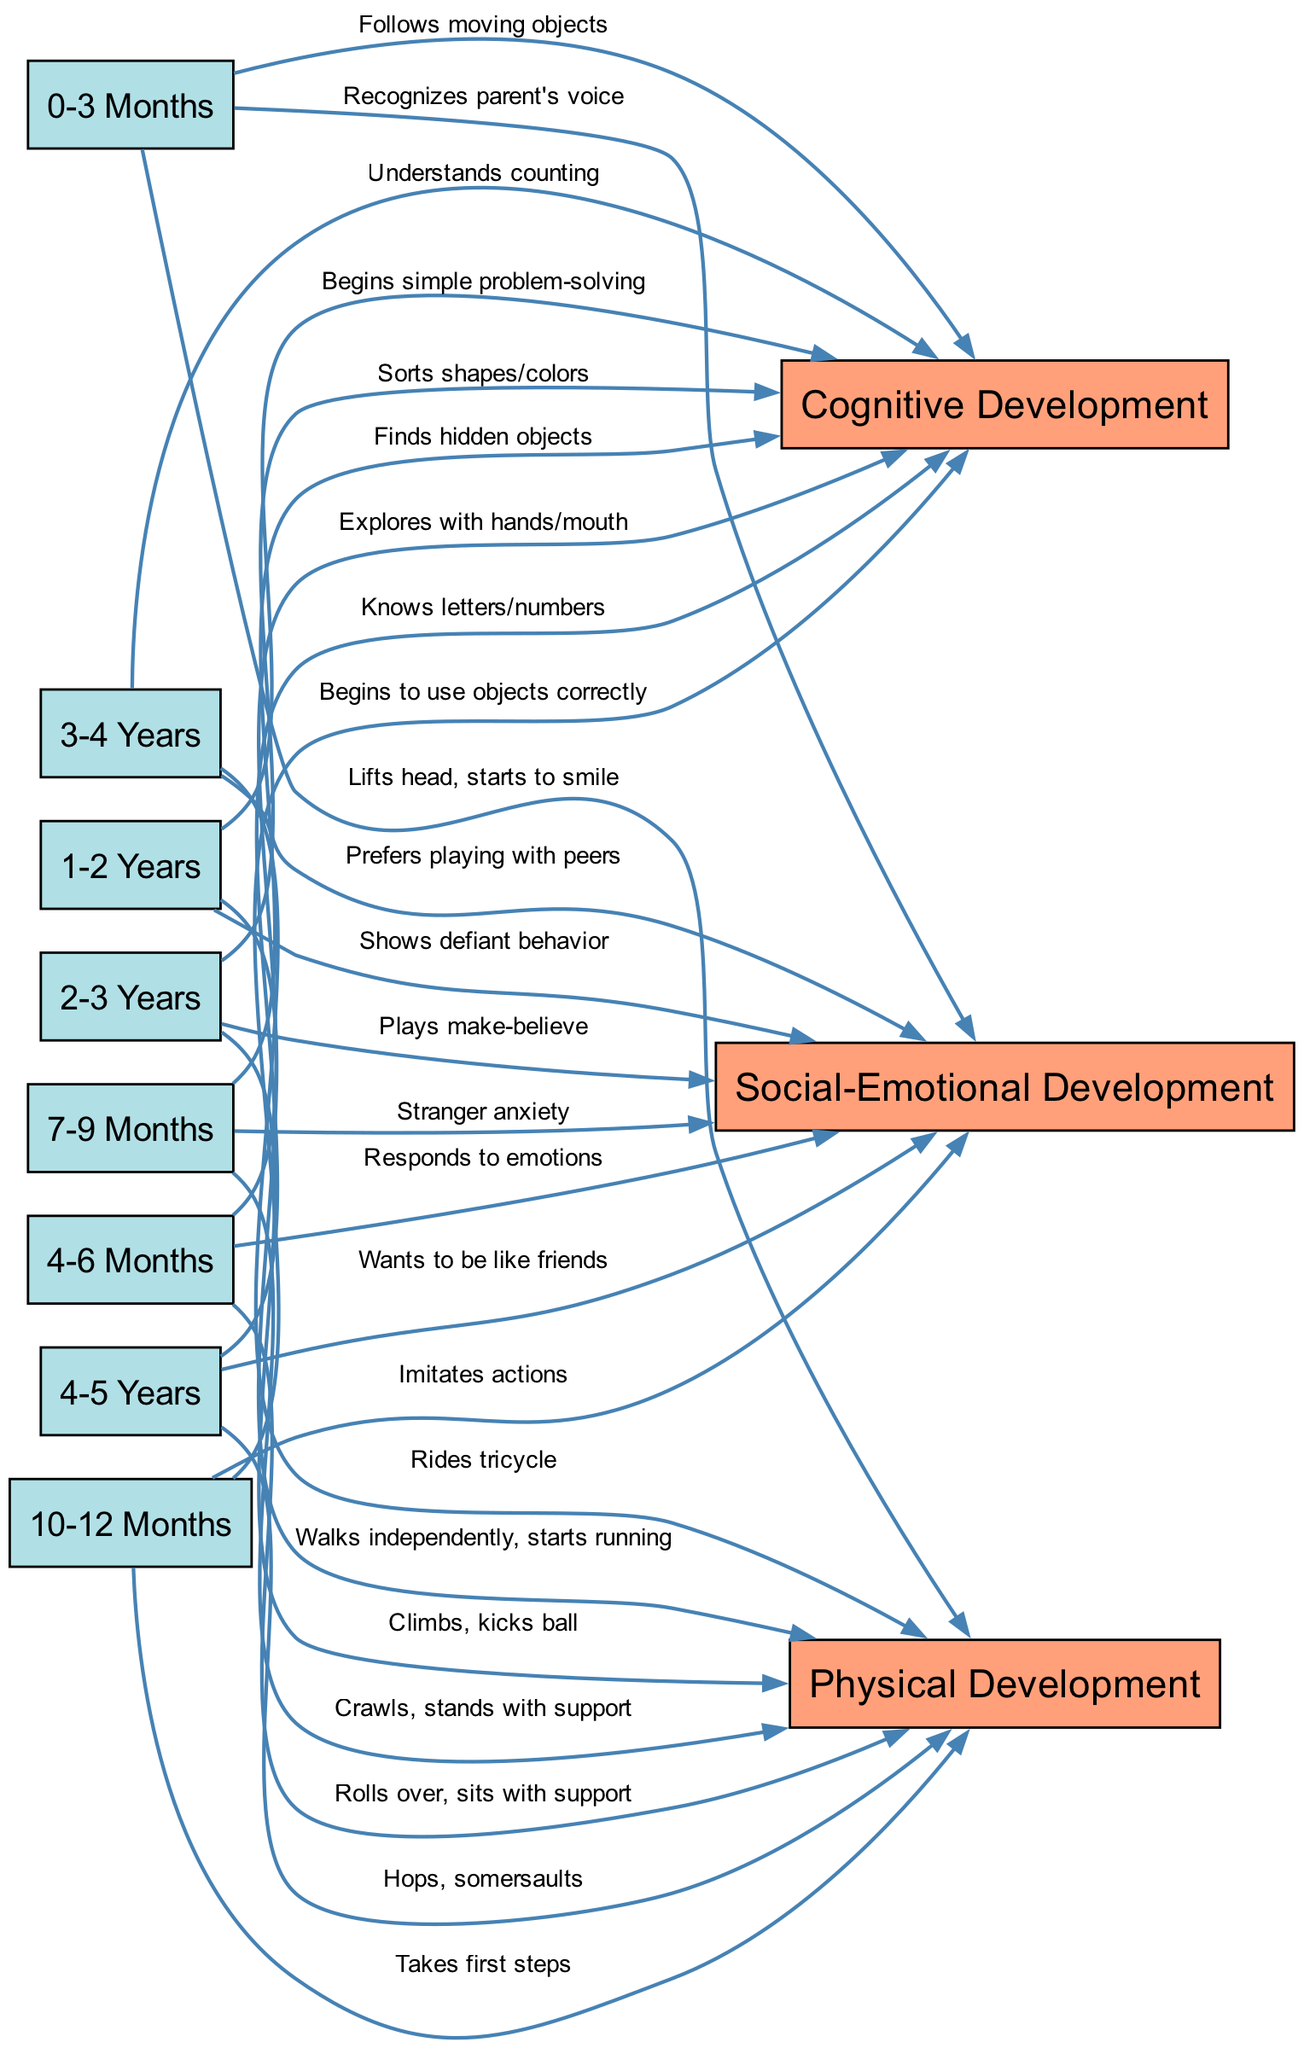What milestones are associated with 1-2 years? The diagram shows three connections for the 1-2 years node: "Walks independently, starts running" for physical development, "Begins simple problem-solving" for cognitive development, and "Shows defiant behavior" for social-emotional development.
Answer: Walks independently, starts running; Begins simple problem-solving; Shows defiant behavior How many nodes are there? The diagram includes a total of 12 nodes which represent both age ranges and types of development.
Answer: 12 What does the 4-6 months node connect to for cognitive development? In the diagram, the 4-6 months node connects to the cognitive development node with the label "Explores with hands/mouth."
Answer: Explores with hands/mouth Which age range corresponds to the milestone "Rides tricycle"? The milestone "Rides tricycle" is connected from the node "3-4 Years." This identifies the age range associated with that specific physical milestone.
Answer: 3-4 Years What is the first milestone in physical development? The diagram connects the 0-3 months node to physical development for the milestone "Lifts head, starts to smile," marking it as the first physical development milestone in the timeline.
Answer: Lifts head, starts to smile Which social-emotional development milestone is noted at 2-3 years? The 2-3 years node connects to social-emotional development with the milestone "Plays make-believe," indicating what social-emotional behavior is expected during this age period.
Answer: Plays make-believe Which milestone indicates crawling and standing with support? This milestone is linked from the 7-9 months node to physical development and is labeled "Crawls, stands with support," thus serving as an important milestone for that age range.
Answer: Crawls, stands with support Which type of development includes the milestone "Knows letters/numbers"? The milestone "Knows letters/numbers" is associated with the 4-5 years node and connects to cognitive development, indicating an important learning stage at that age.
Answer: Cognitive Development 